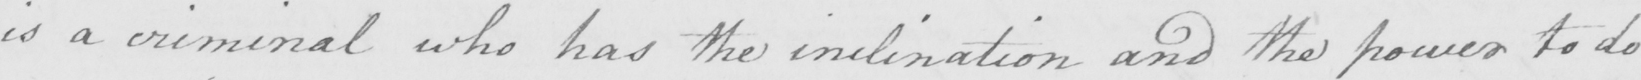Transcribe the text shown in this historical manuscript line. is a criminal who has the inclination and the power to do 